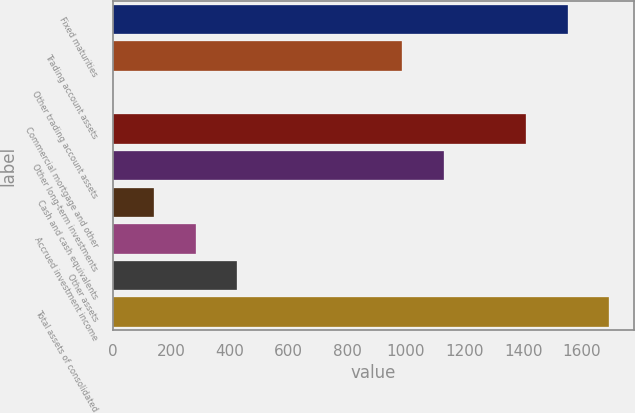Convert chart to OTSL. <chart><loc_0><loc_0><loc_500><loc_500><bar_chart><fcel>Fixed maturities<fcel>Trading account assets<fcel>Other trading account assets<fcel>Commercial mortgage and other<fcel>Other long-term investments<fcel>Cash and cash equivalents<fcel>Accrued investment income<fcel>Other assets<fcel>Total assets of consolidated<nl><fcel>1552.02<fcel>987.98<fcel>0.91<fcel>1411.01<fcel>1128.99<fcel>141.92<fcel>282.93<fcel>423.94<fcel>1693.03<nl></chart> 